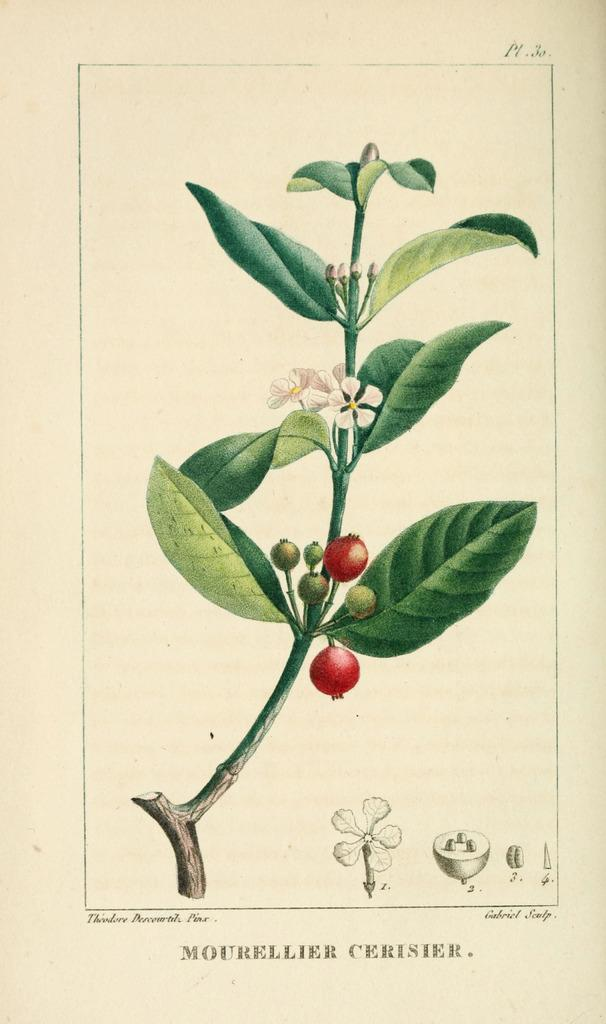What can be seen hanging on the wall in the image? There is a poster in the image. What type of plant is present in the image? There is a plant with flowers in the image. Are there any fruits visible on the plant? Yes, there are fruits on the plant in the image. Can you read any text in the image? There is text on the poster or plant in the image. What type of horn is visible on the plant in the image? There is no horn present on the plant in the image. 